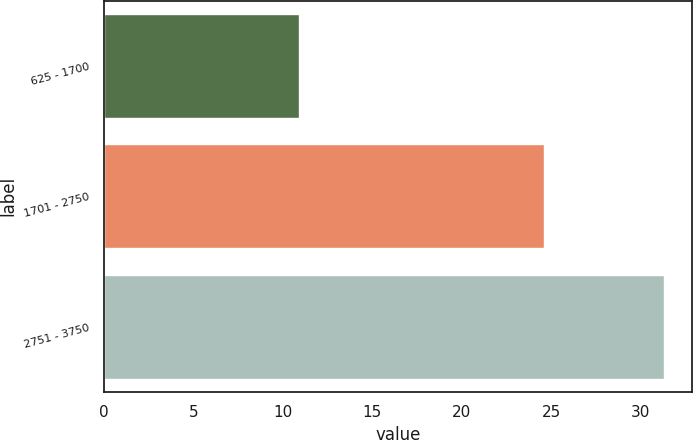Convert chart to OTSL. <chart><loc_0><loc_0><loc_500><loc_500><bar_chart><fcel>625 - 1700<fcel>1701 - 2750<fcel>2751 - 3750<nl><fcel>10.92<fcel>24.59<fcel>31.28<nl></chart> 